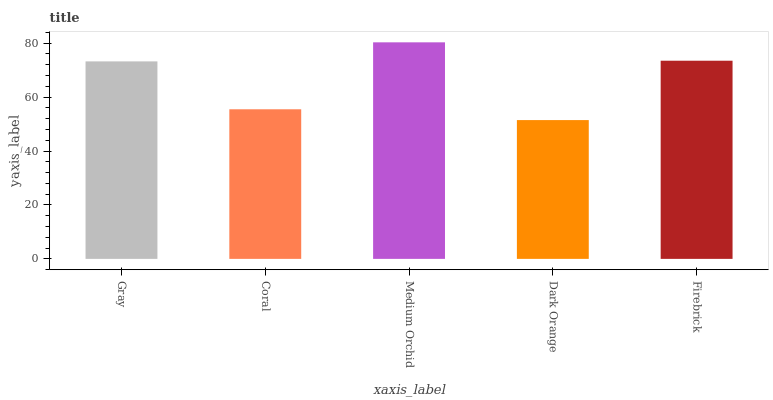Is Dark Orange the minimum?
Answer yes or no. Yes. Is Medium Orchid the maximum?
Answer yes or no. Yes. Is Coral the minimum?
Answer yes or no. No. Is Coral the maximum?
Answer yes or no. No. Is Gray greater than Coral?
Answer yes or no. Yes. Is Coral less than Gray?
Answer yes or no. Yes. Is Coral greater than Gray?
Answer yes or no. No. Is Gray less than Coral?
Answer yes or no. No. Is Gray the high median?
Answer yes or no. Yes. Is Gray the low median?
Answer yes or no. Yes. Is Coral the high median?
Answer yes or no. No. Is Medium Orchid the low median?
Answer yes or no. No. 